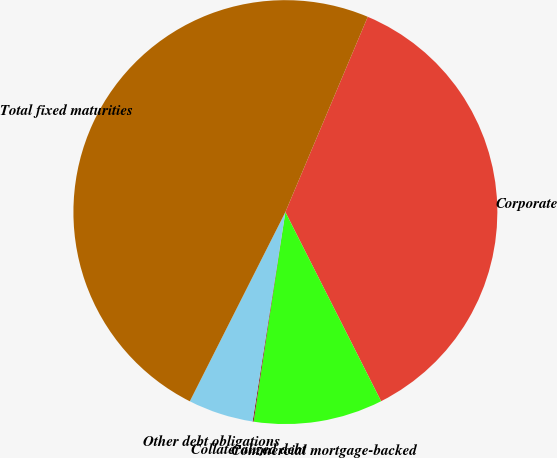<chart> <loc_0><loc_0><loc_500><loc_500><pie_chart><fcel>Corporate<fcel>Commercial mortgage-backed<fcel>Collateralized debt<fcel>Other debt obligations<fcel>Total fixed maturities<nl><fcel>36.19%<fcel>9.85%<fcel>0.08%<fcel>4.97%<fcel>48.91%<nl></chart> 